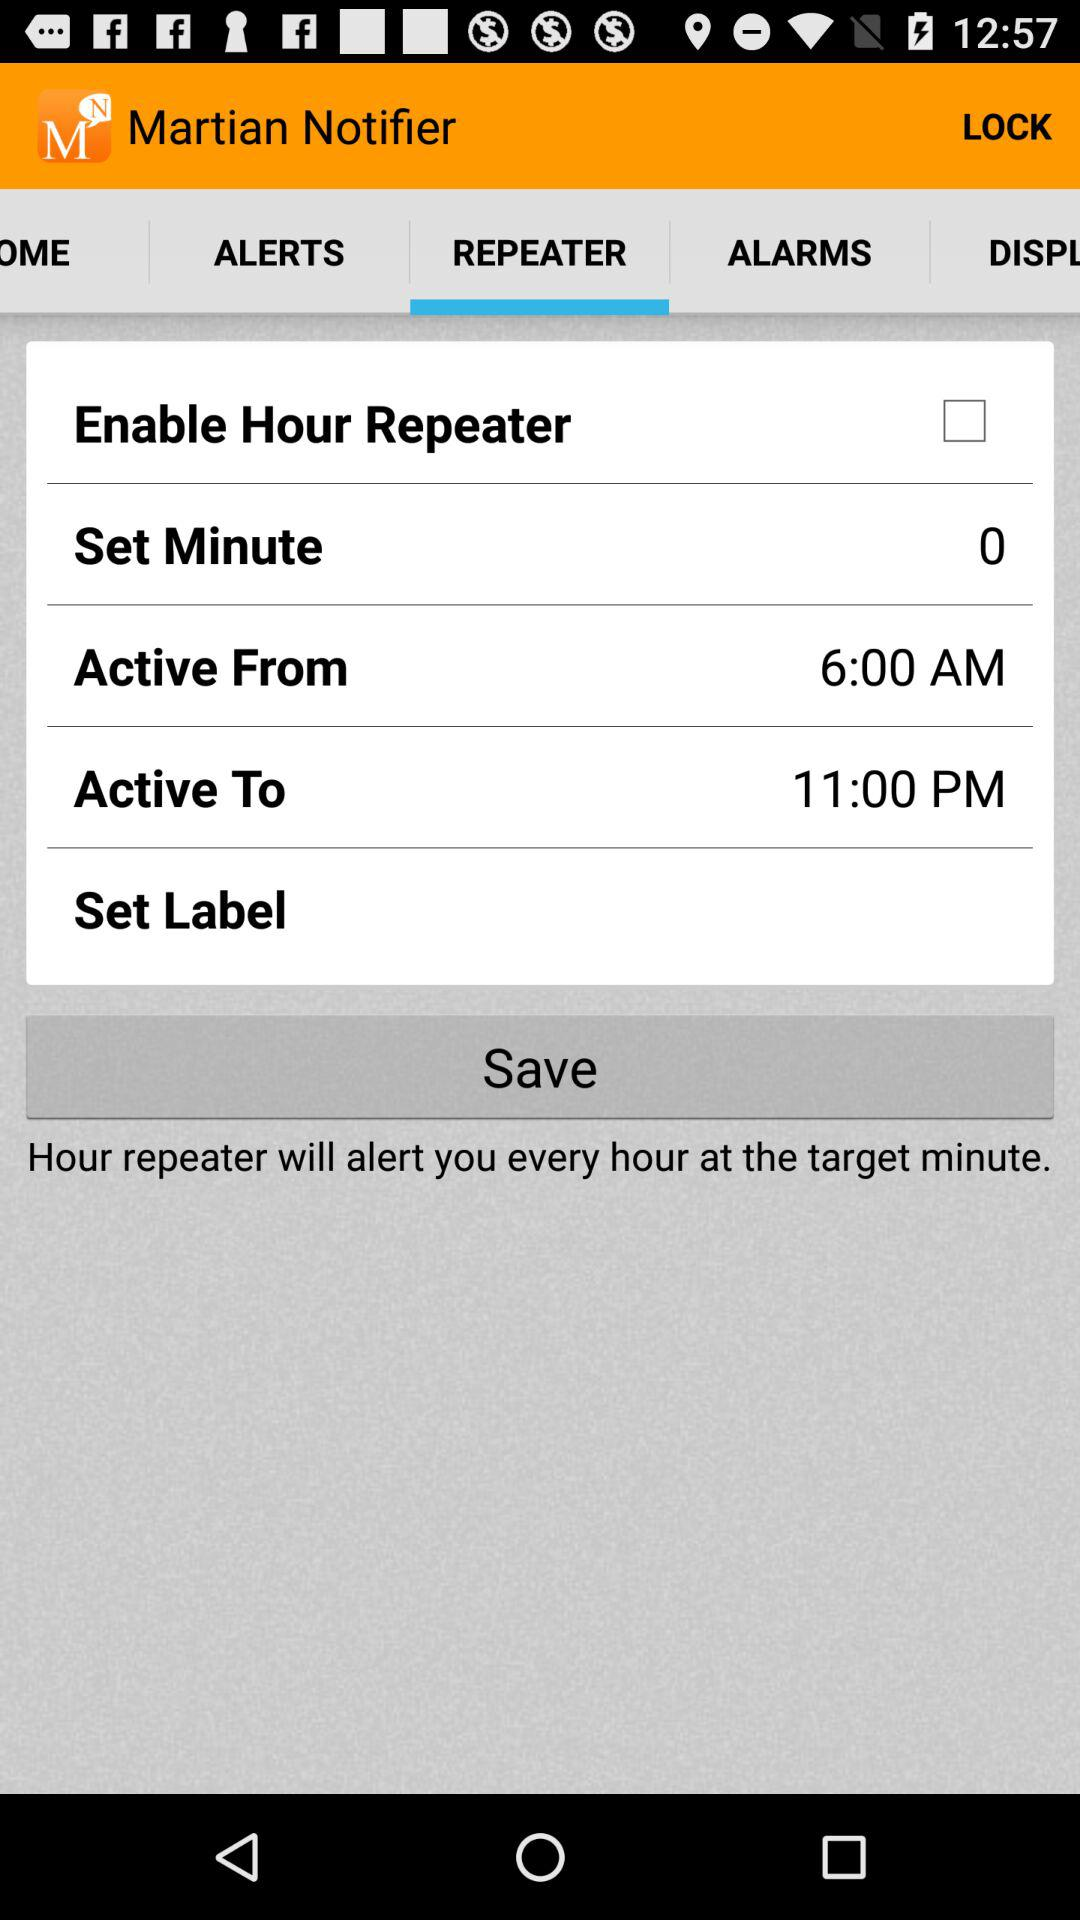At what time was the "Active From" option set? The set time was 6:00 AM. 